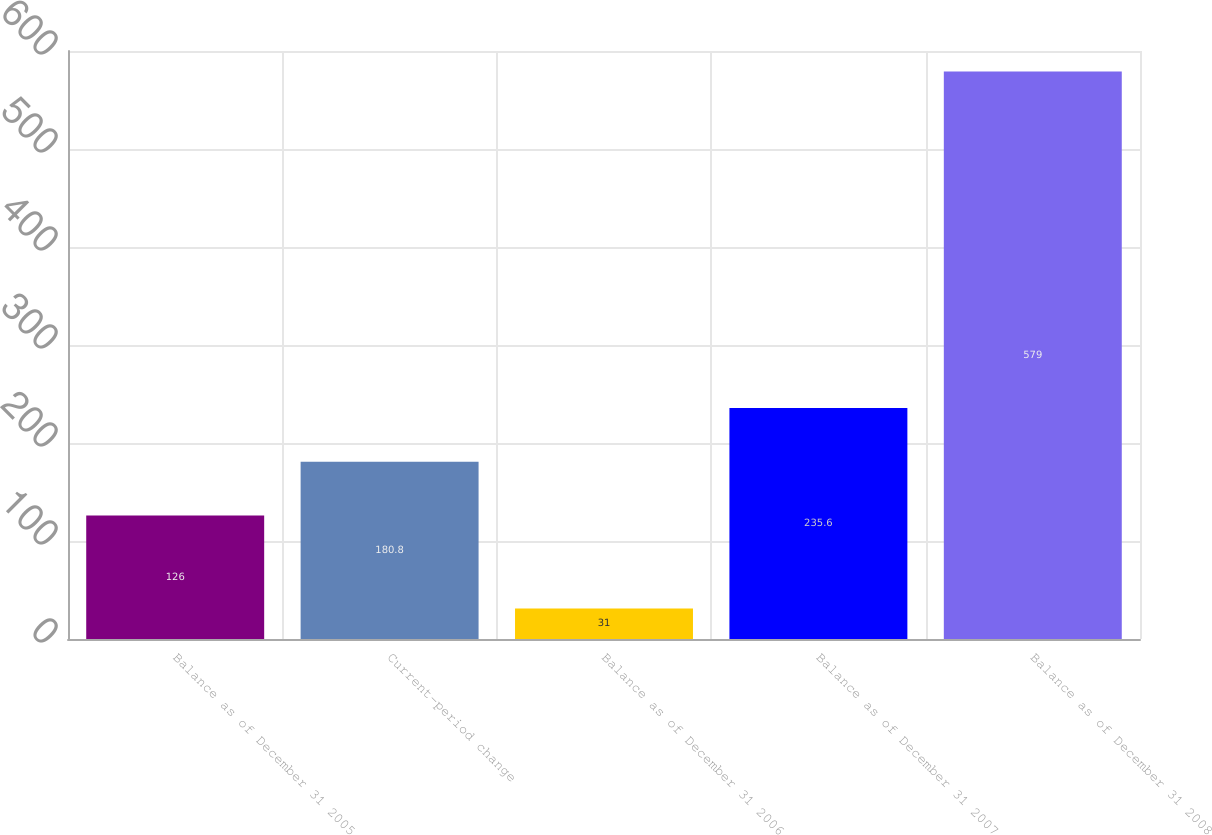Convert chart to OTSL. <chart><loc_0><loc_0><loc_500><loc_500><bar_chart><fcel>Balance as of December 31 2005<fcel>Current-period change<fcel>Balance as of December 31 2006<fcel>Balance as of December 31 2007<fcel>Balance as of December 31 2008<nl><fcel>126<fcel>180.8<fcel>31<fcel>235.6<fcel>579<nl></chart> 